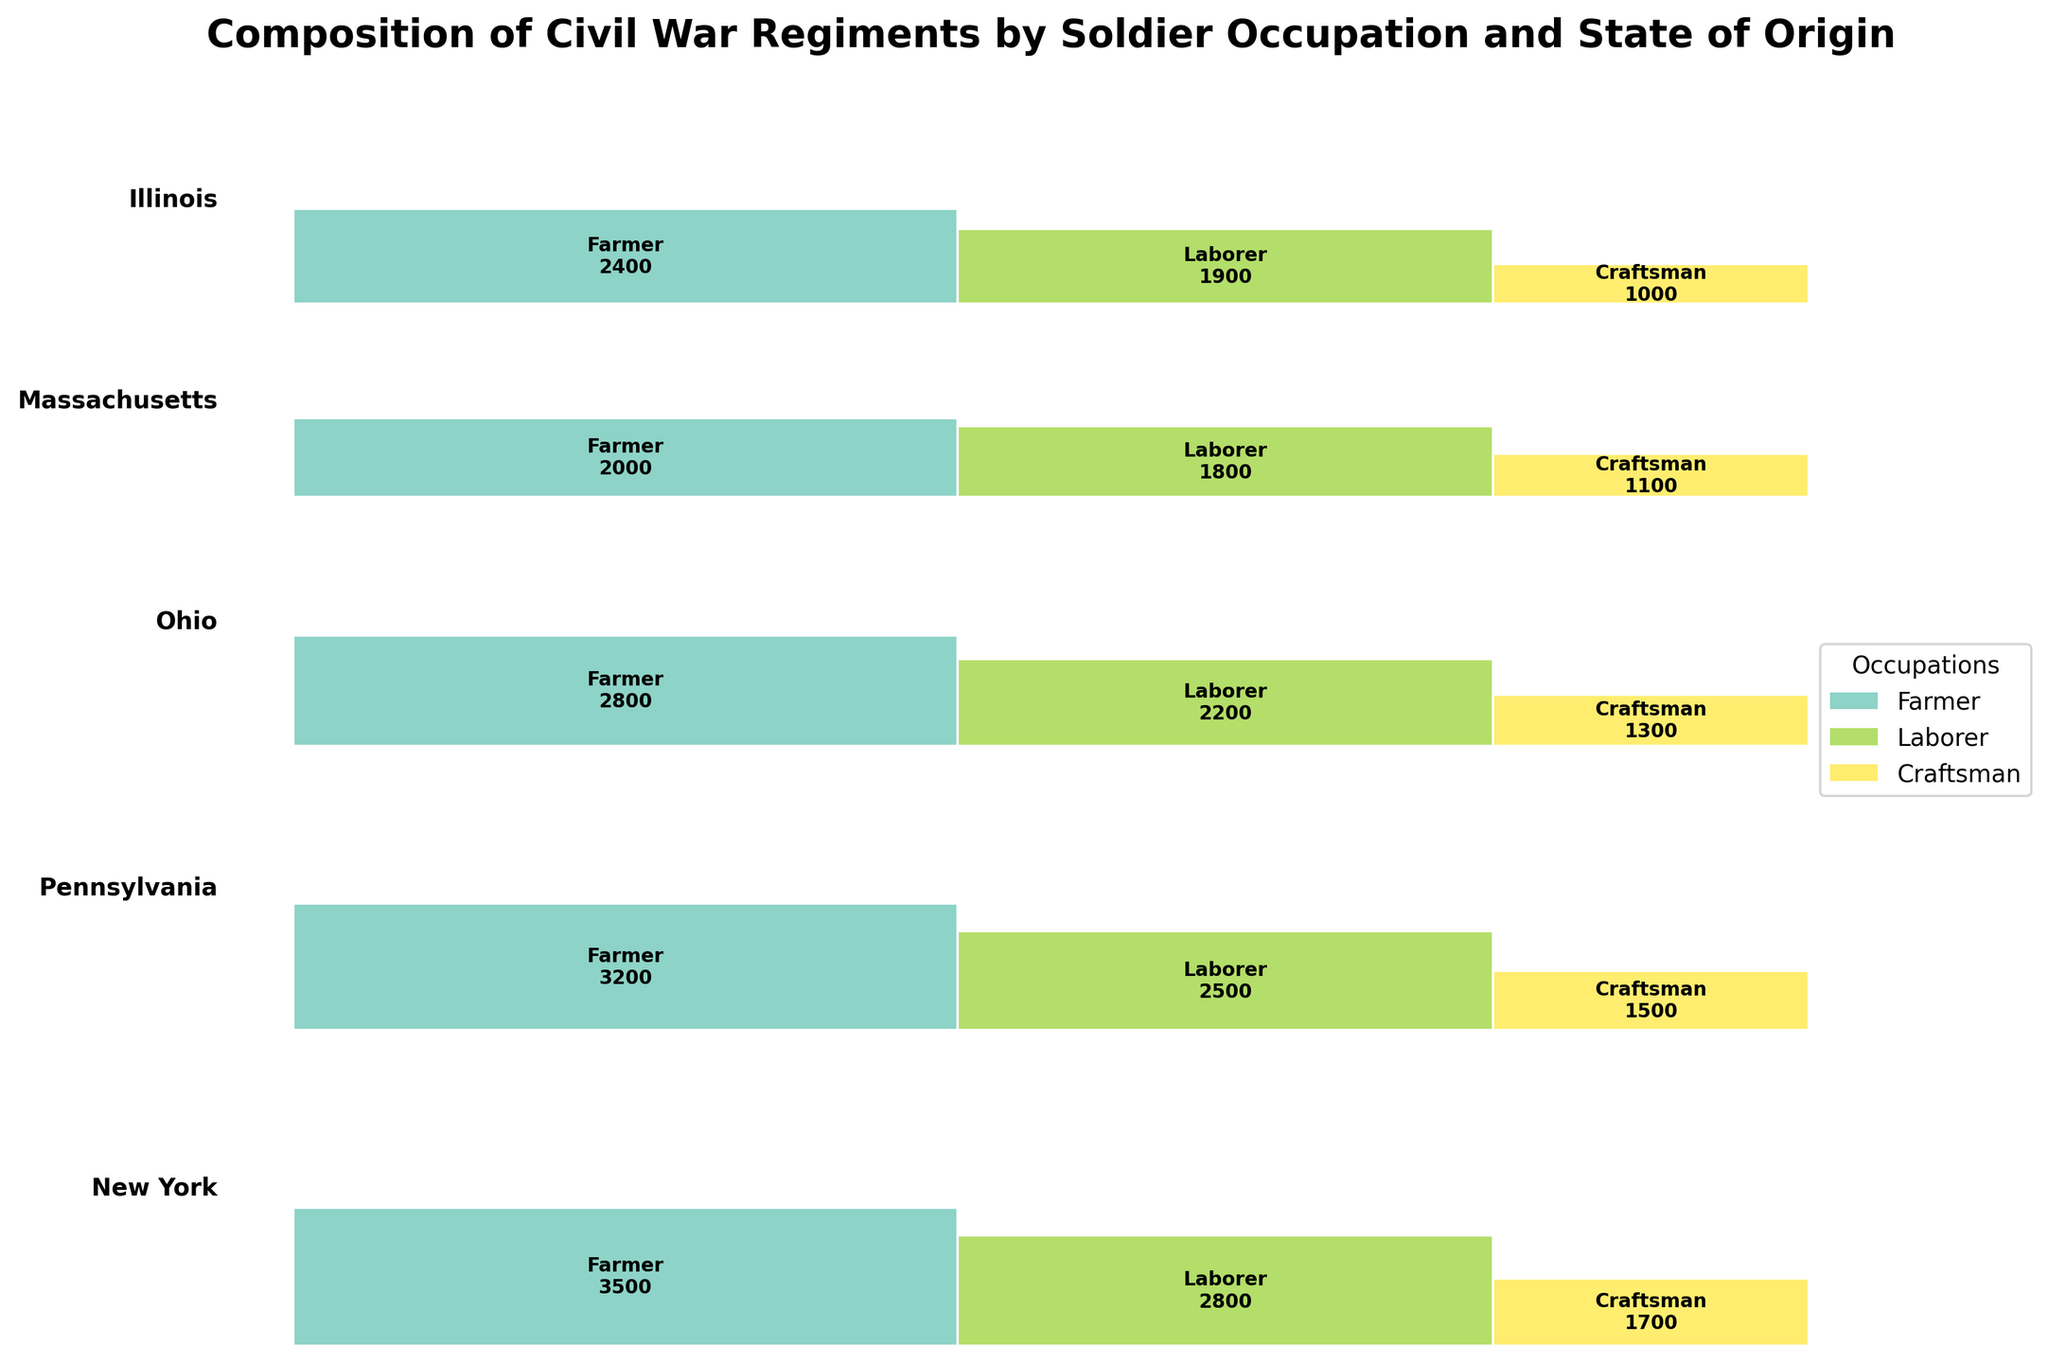What is the total count for Farmers in New York? Look for the rectangle representing Farmers in New York and read the number inside it.
Answer: 3500 Which state has the largest total count of soldiers? Sum the counts of all occupations for each state and compare. New York has 3500 + 2800 + 1700 = 8000; Pennsylvania has 3200 + 2500 + 1500 = 7200; Ohio has 2800 + 2200 + 1300 = 6300; Massachusetts has 2000 + 1800 + 1100 = 4900; Illinois has 2400 + 1900 + 1000 = 5300.
Answer: New York How does the number of Craftsmen soldiers in Ohio compare to those in Massachusetts? Count the number of Craftsmen soldiers in Ohio (1300) and compare it to those in Massachusetts (1100).
Answer: Ohio has more Craftsmen soldiers than Massachusetts What is the proportion of Laborers in Pennsylvania compared to the total number of soldiers in Pennsylvania? Sum the total number of soldiers in Pennsylvania (3200 + 2500 + 1500 = 7200). Then, divide the number of Laborers (2500) by the total (7200) and multiply by 100 to get the percentage.
Answer: Approximately 34.72% Which occupation has the fewest soldiers in Massachusetts and what is the count? Find the rectangle for Massachusetts and compare the counts for Farmer, Laborer, and Craftsman. The Craftsman has the fewest soldiers, at 1100.
Answer: Craftsman, 1100 What is the difference in the number of Farmer soldiers between New York and Illinois? Look at the counts for Farmer soldiers in New York (3500) and Illinois (2400) and subtract Illinois’s count from New York’s count.
Answer: 1100 What state has the smallest contribution of Craftsmen soldiers to its total soldier count? Calculate the contribution of Craftsmen soldiers for each state as a ratio of Craftsmen to total soldiers per state. Compare the ratios. Massachusetts has 1100 Craftsmen out of 4900 total soldiers, yielding approximately 22.45%, which is the smallest ratio compared to other states.
Answer: Massachusetts Which state has more Laborers, New York or Ohio? Look for the rectangles representing Laborers in New York (2800) and Ohio (2200) and compare the counts.
Answer: New York What is the combined total of Craftsmen soldiers across all states? Sum the counts of Craftsmen soldiers from all states: 1700 (NY) + 1500 (PA) + 1300 (OH) + 1100 (MA) + 1000 (IL) = 6600.
Answer: 6600 